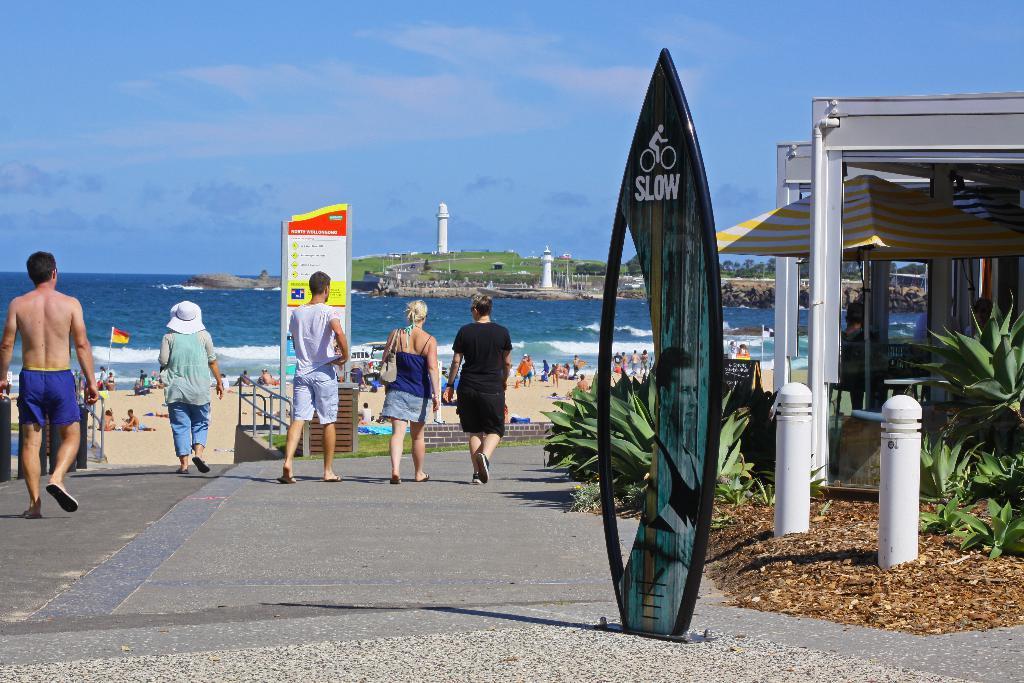In one or two sentences, can you explain what this image depicts? In the image we can see there are people standing on the road and there is a surfing statue kept on the ground. Behind there are people standing and lying on the ground near the sea shore. There are 2 lighthouses on the ground and there is a tent. There is a building and there are plants on the ground. There is a cloudy sky. 